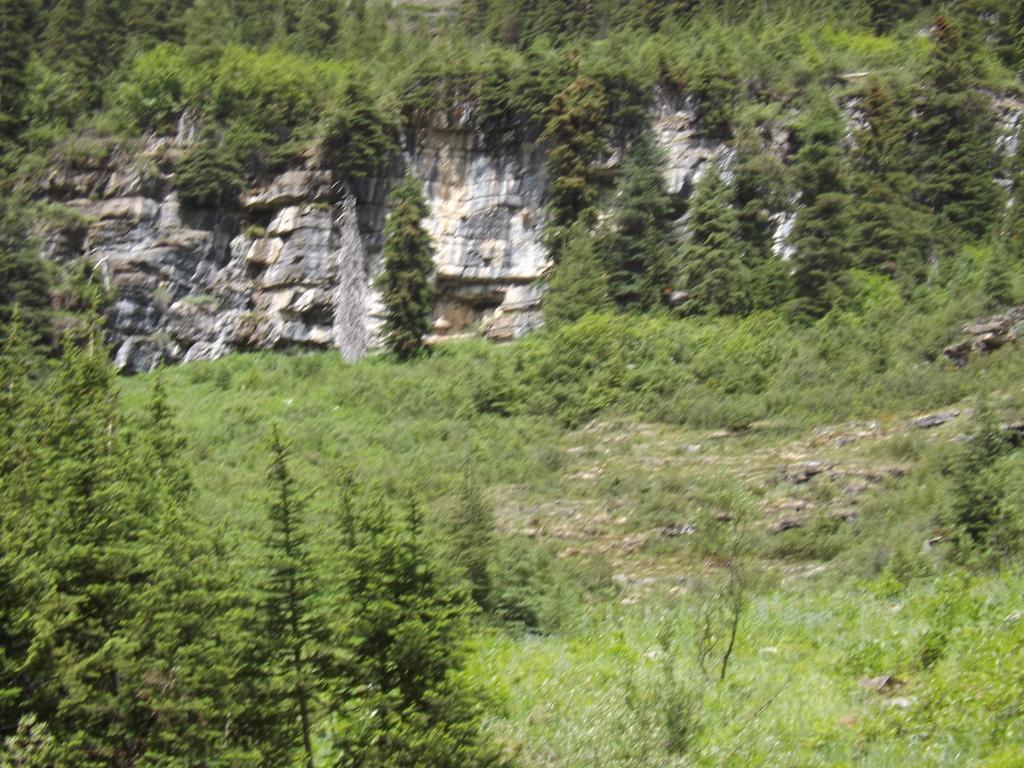Can you describe this image briefly? In this image we can see hill, trees and plants. 